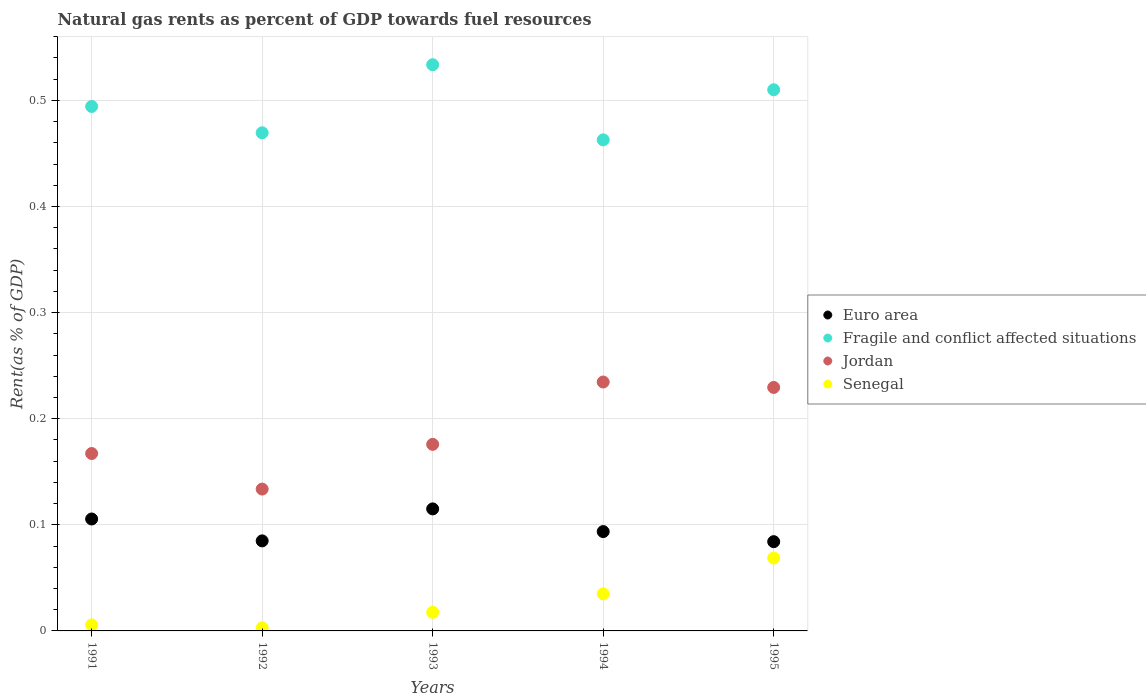What is the matural gas rent in Senegal in 1991?
Make the answer very short. 0.01. Across all years, what is the maximum matural gas rent in Jordan?
Make the answer very short. 0.23. Across all years, what is the minimum matural gas rent in Senegal?
Keep it short and to the point. 0. In which year was the matural gas rent in Euro area minimum?
Your answer should be very brief. 1995. What is the total matural gas rent in Senegal in the graph?
Your answer should be very brief. 0.13. What is the difference between the matural gas rent in Fragile and conflict affected situations in 1994 and that in 1995?
Offer a terse response. -0.05. What is the difference between the matural gas rent in Euro area in 1994 and the matural gas rent in Jordan in 1995?
Ensure brevity in your answer.  -0.14. What is the average matural gas rent in Senegal per year?
Provide a succinct answer. 0.03. In the year 1995, what is the difference between the matural gas rent in Fragile and conflict affected situations and matural gas rent in Euro area?
Ensure brevity in your answer.  0.43. In how many years, is the matural gas rent in Euro area greater than 0.44 %?
Make the answer very short. 0. What is the ratio of the matural gas rent in Fragile and conflict affected situations in 1991 to that in 1993?
Offer a very short reply. 0.93. Is the difference between the matural gas rent in Fragile and conflict affected situations in 1992 and 1995 greater than the difference between the matural gas rent in Euro area in 1992 and 1995?
Your answer should be very brief. No. What is the difference between the highest and the second highest matural gas rent in Euro area?
Ensure brevity in your answer.  0.01. What is the difference between the highest and the lowest matural gas rent in Euro area?
Give a very brief answer. 0.03. In how many years, is the matural gas rent in Jordan greater than the average matural gas rent in Jordan taken over all years?
Offer a very short reply. 2. Is the sum of the matural gas rent in Euro area in 1992 and 1995 greater than the maximum matural gas rent in Jordan across all years?
Make the answer very short. No. Is it the case that in every year, the sum of the matural gas rent in Senegal and matural gas rent in Fragile and conflict affected situations  is greater than the matural gas rent in Jordan?
Provide a succinct answer. Yes. Is the matural gas rent in Jordan strictly less than the matural gas rent in Senegal over the years?
Provide a succinct answer. No. What is the difference between two consecutive major ticks on the Y-axis?
Your answer should be compact. 0.1. How are the legend labels stacked?
Your answer should be very brief. Vertical. What is the title of the graph?
Keep it short and to the point. Natural gas rents as percent of GDP towards fuel resources. What is the label or title of the Y-axis?
Provide a short and direct response. Rent(as % of GDP). What is the Rent(as % of GDP) in Euro area in 1991?
Your answer should be compact. 0.11. What is the Rent(as % of GDP) of Fragile and conflict affected situations in 1991?
Give a very brief answer. 0.49. What is the Rent(as % of GDP) in Jordan in 1991?
Give a very brief answer. 0.17. What is the Rent(as % of GDP) of Senegal in 1991?
Your answer should be compact. 0.01. What is the Rent(as % of GDP) in Euro area in 1992?
Your response must be concise. 0.08. What is the Rent(as % of GDP) in Fragile and conflict affected situations in 1992?
Give a very brief answer. 0.47. What is the Rent(as % of GDP) of Jordan in 1992?
Keep it short and to the point. 0.13. What is the Rent(as % of GDP) of Senegal in 1992?
Offer a very short reply. 0. What is the Rent(as % of GDP) of Euro area in 1993?
Your response must be concise. 0.12. What is the Rent(as % of GDP) in Fragile and conflict affected situations in 1993?
Offer a terse response. 0.53. What is the Rent(as % of GDP) of Jordan in 1993?
Give a very brief answer. 0.18. What is the Rent(as % of GDP) of Senegal in 1993?
Your response must be concise. 0.02. What is the Rent(as % of GDP) of Euro area in 1994?
Your answer should be very brief. 0.09. What is the Rent(as % of GDP) in Fragile and conflict affected situations in 1994?
Your answer should be compact. 0.46. What is the Rent(as % of GDP) of Jordan in 1994?
Your response must be concise. 0.23. What is the Rent(as % of GDP) in Senegal in 1994?
Your answer should be very brief. 0.03. What is the Rent(as % of GDP) in Euro area in 1995?
Provide a succinct answer. 0.08. What is the Rent(as % of GDP) of Fragile and conflict affected situations in 1995?
Keep it short and to the point. 0.51. What is the Rent(as % of GDP) in Jordan in 1995?
Your answer should be compact. 0.23. What is the Rent(as % of GDP) of Senegal in 1995?
Keep it short and to the point. 0.07. Across all years, what is the maximum Rent(as % of GDP) in Euro area?
Your answer should be very brief. 0.12. Across all years, what is the maximum Rent(as % of GDP) in Fragile and conflict affected situations?
Your response must be concise. 0.53. Across all years, what is the maximum Rent(as % of GDP) in Jordan?
Your answer should be compact. 0.23. Across all years, what is the maximum Rent(as % of GDP) of Senegal?
Ensure brevity in your answer.  0.07. Across all years, what is the minimum Rent(as % of GDP) in Euro area?
Your response must be concise. 0.08. Across all years, what is the minimum Rent(as % of GDP) in Fragile and conflict affected situations?
Keep it short and to the point. 0.46. Across all years, what is the minimum Rent(as % of GDP) of Jordan?
Provide a succinct answer. 0.13. Across all years, what is the minimum Rent(as % of GDP) of Senegal?
Provide a succinct answer. 0. What is the total Rent(as % of GDP) of Euro area in the graph?
Ensure brevity in your answer.  0.48. What is the total Rent(as % of GDP) of Fragile and conflict affected situations in the graph?
Your answer should be compact. 2.47. What is the total Rent(as % of GDP) in Jordan in the graph?
Provide a short and direct response. 0.94. What is the total Rent(as % of GDP) of Senegal in the graph?
Give a very brief answer. 0.13. What is the difference between the Rent(as % of GDP) in Euro area in 1991 and that in 1992?
Your response must be concise. 0.02. What is the difference between the Rent(as % of GDP) in Fragile and conflict affected situations in 1991 and that in 1992?
Ensure brevity in your answer.  0.02. What is the difference between the Rent(as % of GDP) in Jordan in 1991 and that in 1992?
Provide a succinct answer. 0.03. What is the difference between the Rent(as % of GDP) in Senegal in 1991 and that in 1992?
Provide a succinct answer. 0. What is the difference between the Rent(as % of GDP) of Euro area in 1991 and that in 1993?
Offer a terse response. -0.01. What is the difference between the Rent(as % of GDP) in Fragile and conflict affected situations in 1991 and that in 1993?
Your answer should be compact. -0.04. What is the difference between the Rent(as % of GDP) in Jordan in 1991 and that in 1993?
Your response must be concise. -0.01. What is the difference between the Rent(as % of GDP) of Senegal in 1991 and that in 1993?
Ensure brevity in your answer.  -0.01. What is the difference between the Rent(as % of GDP) of Euro area in 1991 and that in 1994?
Offer a very short reply. 0.01. What is the difference between the Rent(as % of GDP) in Fragile and conflict affected situations in 1991 and that in 1994?
Provide a short and direct response. 0.03. What is the difference between the Rent(as % of GDP) in Jordan in 1991 and that in 1994?
Provide a short and direct response. -0.07. What is the difference between the Rent(as % of GDP) of Senegal in 1991 and that in 1994?
Your response must be concise. -0.03. What is the difference between the Rent(as % of GDP) of Euro area in 1991 and that in 1995?
Your answer should be very brief. 0.02. What is the difference between the Rent(as % of GDP) of Fragile and conflict affected situations in 1991 and that in 1995?
Make the answer very short. -0.02. What is the difference between the Rent(as % of GDP) of Jordan in 1991 and that in 1995?
Provide a short and direct response. -0.06. What is the difference between the Rent(as % of GDP) of Senegal in 1991 and that in 1995?
Give a very brief answer. -0.06. What is the difference between the Rent(as % of GDP) in Euro area in 1992 and that in 1993?
Offer a very short reply. -0.03. What is the difference between the Rent(as % of GDP) in Fragile and conflict affected situations in 1992 and that in 1993?
Ensure brevity in your answer.  -0.06. What is the difference between the Rent(as % of GDP) in Jordan in 1992 and that in 1993?
Make the answer very short. -0.04. What is the difference between the Rent(as % of GDP) in Senegal in 1992 and that in 1993?
Offer a terse response. -0.01. What is the difference between the Rent(as % of GDP) in Euro area in 1992 and that in 1994?
Ensure brevity in your answer.  -0.01. What is the difference between the Rent(as % of GDP) in Fragile and conflict affected situations in 1992 and that in 1994?
Offer a very short reply. 0.01. What is the difference between the Rent(as % of GDP) in Jordan in 1992 and that in 1994?
Make the answer very short. -0.1. What is the difference between the Rent(as % of GDP) of Senegal in 1992 and that in 1994?
Provide a short and direct response. -0.03. What is the difference between the Rent(as % of GDP) of Euro area in 1992 and that in 1995?
Provide a short and direct response. 0. What is the difference between the Rent(as % of GDP) of Fragile and conflict affected situations in 1992 and that in 1995?
Provide a short and direct response. -0.04. What is the difference between the Rent(as % of GDP) in Jordan in 1992 and that in 1995?
Your response must be concise. -0.1. What is the difference between the Rent(as % of GDP) in Senegal in 1992 and that in 1995?
Ensure brevity in your answer.  -0.07. What is the difference between the Rent(as % of GDP) in Euro area in 1993 and that in 1994?
Your response must be concise. 0.02. What is the difference between the Rent(as % of GDP) in Fragile and conflict affected situations in 1993 and that in 1994?
Provide a succinct answer. 0.07. What is the difference between the Rent(as % of GDP) in Jordan in 1993 and that in 1994?
Make the answer very short. -0.06. What is the difference between the Rent(as % of GDP) of Senegal in 1993 and that in 1994?
Your answer should be very brief. -0.02. What is the difference between the Rent(as % of GDP) in Euro area in 1993 and that in 1995?
Keep it short and to the point. 0.03. What is the difference between the Rent(as % of GDP) in Fragile and conflict affected situations in 1993 and that in 1995?
Your answer should be very brief. 0.02. What is the difference between the Rent(as % of GDP) of Jordan in 1993 and that in 1995?
Keep it short and to the point. -0.05. What is the difference between the Rent(as % of GDP) of Senegal in 1993 and that in 1995?
Provide a short and direct response. -0.05. What is the difference between the Rent(as % of GDP) of Euro area in 1994 and that in 1995?
Your response must be concise. 0.01. What is the difference between the Rent(as % of GDP) of Fragile and conflict affected situations in 1994 and that in 1995?
Your answer should be very brief. -0.05. What is the difference between the Rent(as % of GDP) in Jordan in 1994 and that in 1995?
Ensure brevity in your answer.  0.01. What is the difference between the Rent(as % of GDP) in Senegal in 1994 and that in 1995?
Offer a terse response. -0.03. What is the difference between the Rent(as % of GDP) in Euro area in 1991 and the Rent(as % of GDP) in Fragile and conflict affected situations in 1992?
Offer a terse response. -0.36. What is the difference between the Rent(as % of GDP) of Euro area in 1991 and the Rent(as % of GDP) of Jordan in 1992?
Your response must be concise. -0.03. What is the difference between the Rent(as % of GDP) in Euro area in 1991 and the Rent(as % of GDP) in Senegal in 1992?
Offer a terse response. 0.1. What is the difference between the Rent(as % of GDP) in Fragile and conflict affected situations in 1991 and the Rent(as % of GDP) in Jordan in 1992?
Your answer should be very brief. 0.36. What is the difference between the Rent(as % of GDP) of Fragile and conflict affected situations in 1991 and the Rent(as % of GDP) of Senegal in 1992?
Offer a very short reply. 0.49. What is the difference between the Rent(as % of GDP) in Jordan in 1991 and the Rent(as % of GDP) in Senegal in 1992?
Ensure brevity in your answer.  0.16. What is the difference between the Rent(as % of GDP) of Euro area in 1991 and the Rent(as % of GDP) of Fragile and conflict affected situations in 1993?
Your response must be concise. -0.43. What is the difference between the Rent(as % of GDP) in Euro area in 1991 and the Rent(as % of GDP) in Jordan in 1993?
Your answer should be very brief. -0.07. What is the difference between the Rent(as % of GDP) in Euro area in 1991 and the Rent(as % of GDP) in Senegal in 1993?
Ensure brevity in your answer.  0.09. What is the difference between the Rent(as % of GDP) in Fragile and conflict affected situations in 1991 and the Rent(as % of GDP) in Jordan in 1993?
Your answer should be very brief. 0.32. What is the difference between the Rent(as % of GDP) of Fragile and conflict affected situations in 1991 and the Rent(as % of GDP) of Senegal in 1993?
Provide a short and direct response. 0.48. What is the difference between the Rent(as % of GDP) in Jordan in 1991 and the Rent(as % of GDP) in Senegal in 1993?
Your answer should be compact. 0.15. What is the difference between the Rent(as % of GDP) in Euro area in 1991 and the Rent(as % of GDP) in Fragile and conflict affected situations in 1994?
Give a very brief answer. -0.36. What is the difference between the Rent(as % of GDP) of Euro area in 1991 and the Rent(as % of GDP) of Jordan in 1994?
Your answer should be very brief. -0.13. What is the difference between the Rent(as % of GDP) in Euro area in 1991 and the Rent(as % of GDP) in Senegal in 1994?
Provide a short and direct response. 0.07. What is the difference between the Rent(as % of GDP) in Fragile and conflict affected situations in 1991 and the Rent(as % of GDP) in Jordan in 1994?
Offer a very short reply. 0.26. What is the difference between the Rent(as % of GDP) in Fragile and conflict affected situations in 1991 and the Rent(as % of GDP) in Senegal in 1994?
Make the answer very short. 0.46. What is the difference between the Rent(as % of GDP) in Jordan in 1991 and the Rent(as % of GDP) in Senegal in 1994?
Offer a very short reply. 0.13. What is the difference between the Rent(as % of GDP) in Euro area in 1991 and the Rent(as % of GDP) in Fragile and conflict affected situations in 1995?
Provide a succinct answer. -0.4. What is the difference between the Rent(as % of GDP) of Euro area in 1991 and the Rent(as % of GDP) of Jordan in 1995?
Your response must be concise. -0.12. What is the difference between the Rent(as % of GDP) of Euro area in 1991 and the Rent(as % of GDP) of Senegal in 1995?
Provide a succinct answer. 0.04. What is the difference between the Rent(as % of GDP) in Fragile and conflict affected situations in 1991 and the Rent(as % of GDP) in Jordan in 1995?
Your response must be concise. 0.26. What is the difference between the Rent(as % of GDP) of Fragile and conflict affected situations in 1991 and the Rent(as % of GDP) of Senegal in 1995?
Your response must be concise. 0.43. What is the difference between the Rent(as % of GDP) in Jordan in 1991 and the Rent(as % of GDP) in Senegal in 1995?
Your response must be concise. 0.1. What is the difference between the Rent(as % of GDP) of Euro area in 1992 and the Rent(as % of GDP) of Fragile and conflict affected situations in 1993?
Offer a terse response. -0.45. What is the difference between the Rent(as % of GDP) of Euro area in 1992 and the Rent(as % of GDP) of Jordan in 1993?
Offer a terse response. -0.09. What is the difference between the Rent(as % of GDP) of Euro area in 1992 and the Rent(as % of GDP) of Senegal in 1993?
Offer a very short reply. 0.07. What is the difference between the Rent(as % of GDP) of Fragile and conflict affected situations in 1992 and the Rent(as % of GDP) of Jordan in 1993?
Your response must be concise. 0.29. What is the difference between the Rent(as % of GDP) in Fragile and conflict affected situations in 1992 and the Rent(as % of GDP) in Senegal in 1993?
Offer a terse response. 0.45. What is the difference between the Rent(as % of GDP) of Jordan in 1992 and the Rent(as % of GDP) of Senegal in 1993?
Ensure brevity in your answer.  0.12. What is the difference between the Rent(as % of GDP) of Euro area in 1992 and the Rent(as % of GDP) of Fragile and conflict affected situations in 1994?
Keep it short and to the point. -0.38. What is the difference between the Rent(as % of GDP) of Euro area in 1992 and the Rent(as % of GDP) of Jordan in 1994?
Keep it short and to the point. -0.15. What is the difference between the Rent(as % of GDP) of Euro area in 1992 and the Rent(as % of GDP) of Senegal in 1994?
Provide a succinct answer. 0.05. What is the difference between the Rent(as % of GDP) in Fragile and conflict affected situations in 1992 and the Rent(as % of GDP) in Jordan in 1994?
Your answer should be compact. 0.23. What is the difference between the Rent(as % of GDP) of Fragile and conflict affected situations in 1992 and the Rent(as % of GDP) of Senegal in 1994?
Your answer should be compact. 0.43. What is the difference between the Rent(as % of GDP) of Jordan in 1992 and the Rent(as % of GDP) of Senegal in 1994?
Offer a very short reply. 0.1. What is the difference between the Rent(as % of GDP) of Euro area in 1992 and the Rent(as % of GDP) of Fragile and conflict affected situations in 1995?
Your response must be concise. -0.43. What is the difference between the Rent(as % of GDP) in Euro area in 1992 and the Rent(as % of GDP) in Jordan in 1995?
Provide a succinct answer. -0.14. What is the difference between the Rent(as % of GDP) of Euro area in 1992 and the Rent(as % of GDP) of Senegal in 1995?
Ensure brevity in your answer.  0.02. What is the difference between the Rent(as % of GDP) in Fragile and conflict affected situations in 1992 and the Rent(as % of GDP) in Jordan in 1995?
Your answer should be very brief. 0.24. What is the difference between the Rent(as % of GDP) in Fragile and conflict affected situations in 1992 and the Rent(as % of GDP) in Senegal in 1995?
Your response must be concise. 0.4. What is the difference between the Rent(as % of GDP) in Jordan in 1992 and the Rent(as % of GDP) in Senegal in 1995?
Offer a terse response. 0.07. What is the difference between the Rent(as % of GDP) in Euro area in 1993 and the Rent(as % of GDP) in Fragile and conflict affected situations in 1994?
Offer a terse response. -0.35. What is the difference between the Rent(as % of GDP) of Euro area in 1993 and the Rent(as % of GDP) of Jordan in 1994?
Provide a short and direct response. -0.12. What is the difference between the Rent(as % of GDP) in Euro area in 1993 and the Rent(as % of GDP) in Senegal in 1994?
Give a very brief answer. 0.08. What is the difference between the Rent(as % of GDP) of Fragile and conflict affected situations in 1993 and the Rent(as % of GDP) of Jordan in 1994?
Your answer should be very brief. 0.3. What is the difference between the Rent(as % of GDP) in Fragile and conflict affected situations in 1993 and the Rent(as % of GDP) in Senegal in 1994?
Offer a very short reply. 0.5. What is the difference between the Rent(as % of GDP) in Jordan in 1993 and the Rent(as % of GDP) in Senegal in 1994?
Provide a short and direct response. 0.14. What is the difference between the Rent(as % of GDP) in Euro area in 1993 and the Rent(as % of GDP) in Fragile and conflict affected situations in 1995?
Keep it short and to the point. -0.4. What is the difference between the Rent(as % of GDP) of Euro area in 1993 and the Rent(as % of GDP) of Jordan in 1995?
Your answer should be very brief. -0.11. What is the difference between the Rent(as % of GDP) in Euro area in 1993 and the Rent(as % of GDP) in Senegal in 1995?
Provide a succinct answer. 0.05. What is the difference between the Rent(as % of GDP) of Fragile and conflict affected situations in 1993 and the Rent(as % of GDP) of Jordan in 1995?
Make the answer very short. 0.3. What is the difference between the Rent(as % of GDP) of Fragile and conflict affected situations in 1993 and the Rent(as % of GDP) of Senegal in 1995?
Keep it short and to the point. 0.47. What is the difference between the Rent(as % of GDP) in Jordan in 1993 and the Rent(as % of GDP) in Senegal in 1995?
Your answer should be compact. 0.11. What is the difference between the Rent(as % of GDP) in Euro area in 1994 and the Rent(as % of GDP) in Fragile and conflict affected situations in 1995?
Provide a succinct answer. -0.42. What is the difference between the Rent(as % of GDP) of Euro area in 1994 and the Rent(as % of GDP) of Jordan in 1995?
Offer a terse response. -0.14. What is the difference between the Rent(as % of GDP) of Euro area in 1994 and the Rent(as % of GDP) of Senegal in 1995?
Make the answer very short. 0.03. What is the difference between the Rent(as % of GDP) of Fragile and conflict affected situations in 1994 and the Rent(as % of GDP) of Jordan in 1995?
Provide a succinct answer. 0.23. What is the difference between the Rent(as % of GDP) in Fragile and conflict affected situations in 1994 and the Rent(as % of GDP) in Senegal in 1995?
Provide a short and direct response. 0.39. What is the difference between the Rent(as % of GDP) of Jordan in 1994 and the Rent(as % of GDP) of Senegal in 1995?
Offer a very short reply. 0.17. What is the average Rent(as % of GDP) of Euro area per year?
Your response must be concise. 0.1. What is the average Rent(as % of GDP) of Fragile and conflict affected situations per year?
Provide a succinct answer. 0.49. What is the average Rent(as % of GDP) in Jordan per year?
Your answer should be very brief. 0.19. What is the average Rent(as % of GDP) of Senegal per year?
Your answer should be compact. 0.03. In the year 1991, what is the difference between the Rent(as % of GDP) in Euro area and Rent(as % of GDP) in Fragile and conflict affected situations?
Your response must be concise. -0.39. In the year 1991, what is the difference between the Rent(as % of GDP) in Euro area and Rent(as % of GDP) in Jordan?
Your response must be concise. -0.06. In the year 1991, what is the difference between the Rent(as % of GDP) of Euro area and Rent(as % of GDP) of Senegal?
Your answer should be compact. 0.1. In the year 1991, what is the difference between the Rent(as % of GDP) in Fragile and conflict affected situations and Rent(as % of GDP) in Jordan?
Your response must be concise. 0.33. In the year 1991, what is the difference between the Rent(as % of GDP) of Fragile and conflict affected situations and Rent(as % of GDP) of Senegal?
Offer a very short reply. 0.49. In the year 1991, what is the difference between the Rent(as % of GDP) in Jordan and Rent(as % of GDP) in Senegal?
Your response must be concise. 0.16. In the year 1992, what is the difference between the Rent(as % of GDP) of Euro area and Rent(as % of GDP) of Fragile and conflict affected situations?
Your response must be concise. -0.38. In the year 1992, what is the difference between the Rent(as % of GDP) of Euro area and Rent(as % of GDP) of Jordan?
Offer a terse response. -0.05. In the year 1992, what is the difference between the Rent(as % of GDP) in Euro area and Rent(as % of GDP) in Senegal?
Your answer should be compact. 0.08. In the year 1992, what is the difference between the Rent(as % of GDP) of Fragile and conflict affected situations and Rent(as % of GDP) of Jordan?
Your answer should be compact. 0.34. In the year 1992, what is the difference between the Rent(as % of GDP) in Fragile and conflict affected situations and Rent(as % of GDP) in Senegal?
Ensure brevity in your answer.  0.47. In the year 1992, what is the difference between the Rent(as % of GDP) of Jordan and Rent(as % of GDP) of Senegal?
Ensure brevity in your answer.  0.13. In the year 1993, what is the difference between the Rent(as % of GDP) of Euro area and Rent(as % of GDP) of Fragile and conflict affected situations?
Ensure brevity in your answer.  -0.42. In the year 1993, what is the difference between the Rent(as % of GDP) in Euro area and Rent(as % of GDP) in Jordan?
Give a very brief answer. -0.06. In the year 1993, what is the difference between the Rent(as % of GDP) of Euro area and Rent(as % of GDP) of Senegal?
Ensure brevity in your answer.  0.1. In the year 1993, what is the difference between the Rent(as % of GDP) in Fragile and conflict affected situations and Rent(as % of GDP) in Jordan?
Your answer should be compact. 0.36. In the year 1993, what is the difference between the Rent(as % of GDP) of Fragile and conflict affected situations and Rent(as % of GDP) of Senegal?
Your answer should be very brief. 0.52. In the year 1993, what is the difference between the Rent(as % of GDP) in Jordan and Rent(as % of GDP) in Senegal?
Your answer should be very brief. 0.16. In the year 1994, what is the difference between the Rent(as % of GDP) in Euro area and Rent(as % of GDP) in Fragile and conflict affected situations?
Your answer should be very brief. -0.37. In the year 1994, what is the difference between the Rent(as % of GDP) in Euro area and Rent(as % of GDP) in Jordan?
Offer a terse response. -0.14. In the year 1994, what is the difference between the Rent(as % of GDP) of Euro area and Rent(as % of GDP) of Senegal?
Ensure brevity in your answer.  0.06. In the year 1994, what is the difference between the Rent(as % of GDP) in Fragile and conflict affected situations and Rent(as % of GDP) in Jordan?
Your response must be concise. 0.23. In the year 1994, what is the difference between the Rent(as % of GDP) of Fragile and conflict affected situations and Rent(as % of GDP) of Senegal?
Give a very brief answer. 0.43. In the year 1994, what is the difference between the Rent(as % of GDP) of Jordan and Rent(as % of GDP) of Senegal?
Your answer should be very brief. 0.2. In the year 1995, what is the difference between the Rent(as % of GDP) of Euro area and Rent(as % of GDP) of Fragile and conflict affected situations?
Make the answer very short. -0.43. In the year 1995, what is the difference between the Rent(as % of GDP) in Euro area and Rent(as % of GDP) in Jordan?
Your answer should be very brief. -0.15. In the year 1995, what is the difference between the Rent(as % of GDP) of Euro area and Rent(as % of GDP) of Senegal?
Your answer should be compact. 0.02. In the year 1995, what is the difference between the Rent(as % of GDP) in Fragile and conflict affected situations and Rent(as % of GDP) in Jordan?
Provide a short and direct response. 0.28. In the year 1995, what is the difference between the Rent(as % of GDP) in Fragile and conflict affected situations and Rent(as % of GDP) in Senegal?
Ensure brevity in your answer.  0.44. In the year 1995, what is the difference between the Rent(as % of GDP) of Jordan and Rent(as % of GDP) of Senegal?
Make the answer very short. 0.16. What is the ratio of the Rent(as % of GDP) in Euro area in 1991 to that in 1992?
Your answer should be compact. 1.24. What is the ratio of the Rent(as % of GDP) in Fragile and conflict affected situations in 1991 to that in 1992?
Provide a succinct answer. 1.05. What is the ratio of the Rent(as % of GDP) in Jordan in 1991 to that in 1992?
Your answer should be compact. 1.25. What is the ratio of the Rent(as % of GDP) of Senegal in 1991 to that in 1992?
Your response must be concise. 1.92. What is the ratio of the Rent(as % of GDP) in Euro area in 1991 to that in 1993?
Your answer should be very brief. 0.92. What is the ratio of the Rent(as % of GDP) in Fragile and conflict affected situations in 1991 to that in 1993?
Your response must be concise. 0.93. What is the ratio of the Rent(as % of GDP) in Jordan in 1991 to that in 1993?
Your answer should be compact. 0.95. What is the ratio of the Rent(as % of GDP) in Senegal in 1991 to that in 1993?
Offer a very short reply. 0.32. What is the ratio of the Rent(as % of GDP) in Euro area in 1991 to that in 1994?
Offer a terse response. 1.13. What is the ratio of the Rent(as % of GDP) of Fragile and conflict affected situations in 1991 to that in 1994?
Give a very brief answer. 1.07. What is the ratio of the Rent(as % of GDP) in Jordan in 1991 to that in 1994?
Give a very brief answer. 0.71. What is the ratio of the Rent(as % of GDP) of Senegal in 1991 to that in 1994?
Ensure brevity in your answer.  0.16. What is the ratio of the Rent(as % of GDP) of Euro area in 1991 to that in 1995?
Provide a succinct answer. 1.25. What is the ratio of the Rent(as % of GDP) of Fragile and conflict affected situations in 1991 to that in 1995?
Offer a terse response. 0.97. What is the ratio of the Rent(as % of GDP) of Jordan in 1991 to that in 1995?
Provide a succinct answer. 0.73. What is the ratio of the Rent(as % of GDP) in Senegal in 1991 to that in 1995?
Offer a terse response. 0.08. What is the ratio of the Rent(as % of GDP) in Euro area in 1992 to that in 1993?
Your answer should be very brief. 0.74. What is the ratio of the Rent(as % of GDP) of Fragile and conflict affected situations in 1992 to that in 1993?
Make the answer very short. 0.88. What is the ratio of the Rent(as % of GDP) of Jordan in 1992 to that in 1993?
Provide a succinct answer. 0.76. What is the ratio of the Rent(as % of GDP) of Senegal in 1992 to that in 1993?
Offer a terse response. 0.17. What is the ratio of the Rent(as % of GDP) in Euro area in 1992 to that in 1994?
Give a very brief answer. 0.91. What is the ratio of the Rent(as % of GDP) of Fragile and conflict affected situations in 1992 to that in 1994?
Keep it short and to the point. 1.01. What is the ratio of the Rent(as % of GDP) of Jordan in 1992 to that in 1994?
Your answer should be very brief. 0.57. What is the ratio of the Rent(as % of GDP) in Senegal in 1992 to that in 1994?
Your answer should be compact. 0.09. What is the ratio of the Rent(as % of GDP) in Euro area in 1992 to that in 1995?
Offer a very short reply. 1.01. What is the ratio of the Rent(as % of GDP) of Fragile and conflict affected situations in 1992 to that in 1995?
Make the answer very short. 0.92. What is the ratio of the Rent(as % of GDP) in Jordan in 1992 to that in 1995?
Make the answer very short. 0.58. What is the ratio of the Rent(as % of GDP) of Senegal in 1992 to that in 1995?
Your answer should be very brief. 0.04. What is the ratio of the Rent(as % of GDP) of Euro area in 1993 to that in 1994?
Ensure brevity in your answer.  1.23. What is the ratio of the Rent(as % of GDP) in Fragile and conflict affected situations in 1993 to that in 1994?
Provide a succinct answer. 1.15. What is the ratio of the Rent(as % of GDP) of Jordan in 1993 to that in 1994?
Ensure brevity in your answer.  0.75. What is the ratio of the Rent(as % of GDP) in Senegal in 1993 to that in 1994?
Make the answer very short. 0.5. What is the ratio of the Rent(as % of GDP) of Euro area in 1993 to that in 1995?
Ensure brevity in your answer.  1.37. What is the ratio of the Rent(as % of GDP) in Fragile and conflict affected situations in 1993 to that in 1995?
Offer a terse response. 1.05. What is the ratio of the Rent(as % of GDP) in Jordan in 1993 to that in 1995?
Your response must be concise. 0.77. What is the ratio of the Rent(as % of GDP) of Senegal in 1993 to that in 1995?
Offer a terse response. 0.26. What is the ratio of the Rent(as % of GDP) of Euro area in 1994 to that in 1995?
Offer a terse response. 1.11. What is the ratio of the Rent(as % of GDP) of Fragile and conflict affected situations in 1994 to that in 1995?
Provide a succinct answer. 0.91. What is the ratio of the Rent(as % of GDP) of Jordan in 1994 to that in 1995?
Your response must be concise. 1.02. What is the ratio of the Rent(as % of GDP) in Senegal in 1994 to that in 1995?
Give a very brief answer. 0.51. What is the difference between the highest and the second highest Rent(as % of GDP) in Euro area?
Your answer should be compact. 0.01. What is the difference between the highest and the second highest Rent(as % of GDP) in Fragile and conflict affected situations?
Make the answer very short. 0.02. What is the difference between the highest and the second highest Rent(as % of GDP) in Jordan?
Make the answer very short. 0.01. What is the difference between the highest and the second highest Rent(as % of GDP) of Senegal?
Your response must be concise. 0.03. What is the difference between the highest and the lowest Rent(as % of GDP) in Euro area?
Your answer should be very brief. 0.03. What is the difference between the highest and the lowest Rent(as % of GDP) in Fragile and conflict affected situations?
Keep it short and to the point. 0.07. What is the difference between the highest and the lowest Rent(as % of GDP) in Jordan?
Your response must be concise. 0.1. What is the difference between the highest and the lowest Rent(as % of GDP) of Senegal?
Provide a short and direct response. 0.07. 